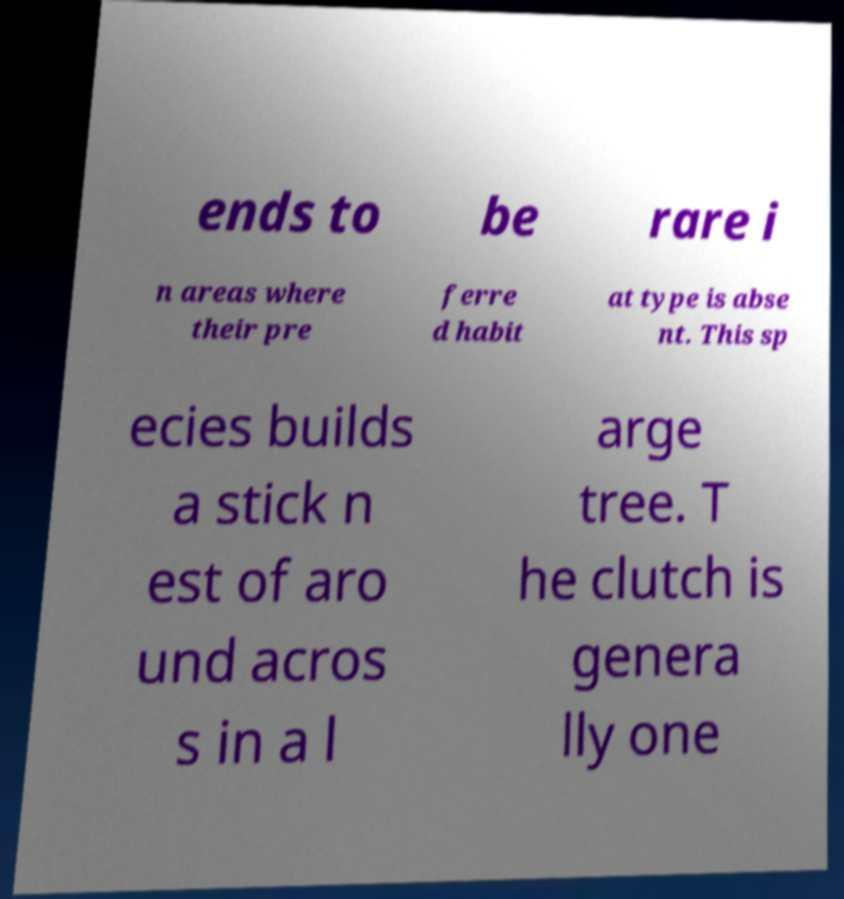Could you assist in decoding the text presented in this image and type it out clearly? ends to be rare i n areas where their pre ferre d habit at type is abse nt. This sp ecies builds a stick n est of aro und acros s in a l arge tree. T he clutch is genera lly one 